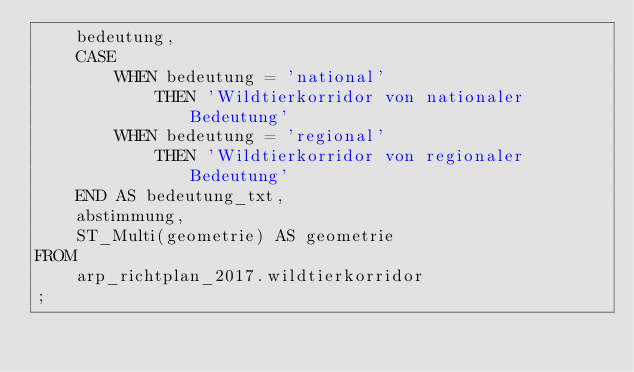Convert code to text. <code><loc_0><loc_0><loc_500><loc_500><_SQL_>    bedeutung,
    CASE
        WHEN bedeutung = 'national'
            THEN 'Wildtierkorridor von nationaler Bedeutung'
        WHEN bedeutung = 'regional'
            THEN 'Wildtierkorridor von regionaler Bedeutung'
    END AS bedeutung_txt,
    abstimmung,
    ST_Multi(geometrie) AS geometrie 
FROM
    arp_richtplan_2017.wildtierkorridor
;</code> 